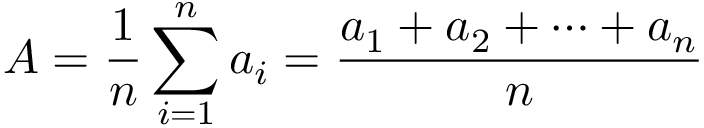Convert formula to latex. <formula><loc_0><loc_0><loc_500><loc_500>A = { \frac { 1 } { n } } \sum _ { i = 1 } ^ { n } a _ { i } = { \frac { a _ { 1 } + a _ { 2 } + \cdots + a _ { n } } { n } }</formula> 